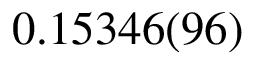Convert formula to latex. <formula><loc_0><loc_0><loc_500><loc_500>0 . 1 5 3 4 6 ( 9 6 )</formula> 